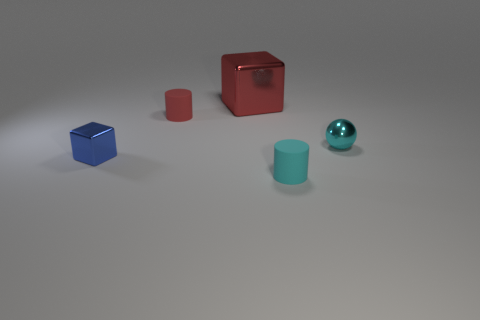Add 5 small balls. How many objects exist? 10 Subtract all cubes. How many objects are left? 3 Add 4 cyan rubber things. How many cyan rubber things exist? 5 Subtract 0 purple cylinders. How many objects are left? 5 Subtract all large red metallic blocks. Subtract all red matte objects. How many objects are left? 3 Add 5 blue metallic blocks. How many blue metallic blocks are left? 6 